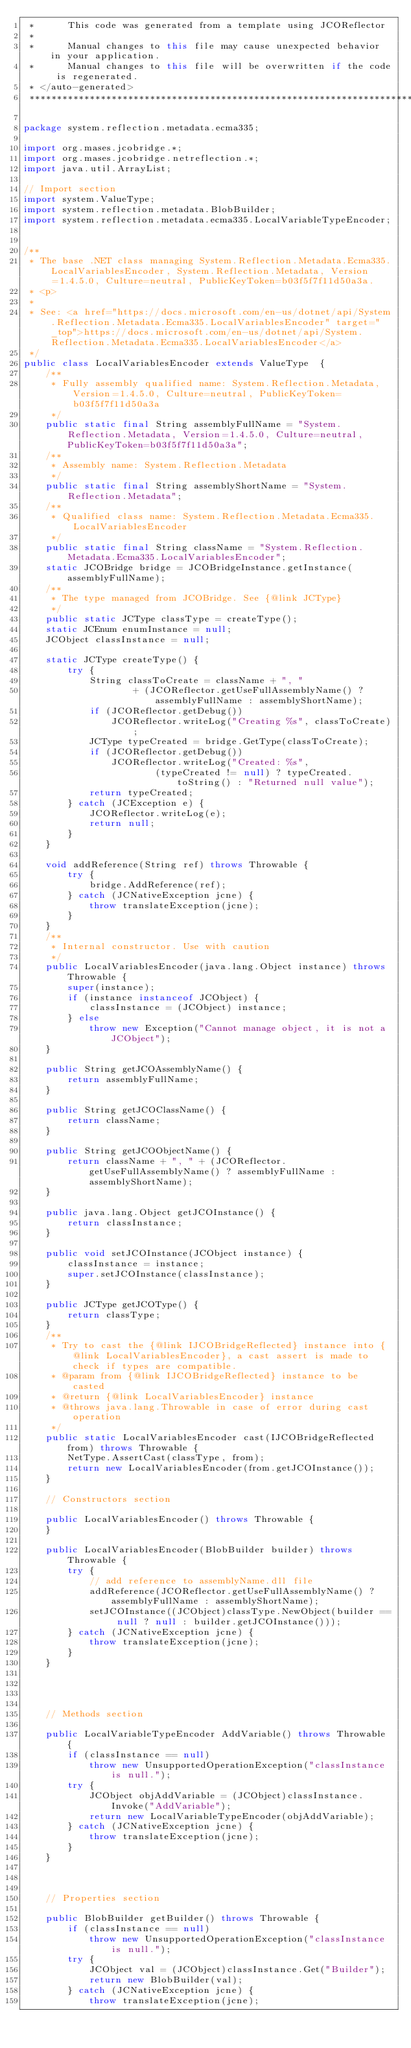Convert code to text. <code><loc_0><loc_0><loc_500><loc_500><_Java_> *      This code was generated from a template using JCOReflector
 * 
 *      Manual changes to this file may cause unexpected behavior in your application.
 *      Manual changes to this file will be overwritten if the code is regenerated.
 * </auto-generated>
 *************************************************************************************/

package system.reflection.metadata.ecma335;

import org.mases.jcobridge.*;
import org.mases.jcobridge.netreflection.*;
import java.util.ArrayList;

// Import section
import system.ValueType;
import system.reflection.metadata.BlobBuilder;
import system.reflection.metadata.ecma335.LocalVariableTypeEncoder;


/**
 * The base .NET class managing System.Reflection.Metadata.Ecma335.LocalVariablesEncoder, System.Reflection.Metadata, Version=1.4.5.0, Culture=neutral, PublicKeyToken=b03f5f7f11d50a3a.
 * <p>
 * 
 * See: <a href="https://docs.microsoft.com/en-us/dotnet/api/System.Reflection.Metadata.Ecma335.LocalVariablesEncoder" target="_top">https://docs.microsoft.com/en-us/dotnet/api/System.Reflection.Metadata.Ecma335.LocalVariablesEncoder</a>
 */
public class LocalVariablesEncoder extends ValueType  {
    /**
     * Fully assembly qualified name: System.Reflection.Metadata, Version=1.4.5.0, Culture=neutral, PublicKeyToken=b03f5f7f11d50a3a
     */
    public static final String assemblyFullName = "System.Reflection.Metadata, Version=1.4.5.0, Culture=neutral, PublicKeyToken=b03f5f7f11d50a3a";
    /**
     * Assembly name: System.Reflection.Metadata
     */
    public static final String assemblyShortName = "System.Reflection.Metadata";
    /**
     * Qualified class name: System.Reflection.Metadata.Ecma335.LocalVariablesEncoder
     */
    public static final String className = "System.Reflection.Metadata.Ecma335.LocalVariablesEncoder";
    static JCOBridge bridge = JCOBridgeInstance.getInstance(assemblyFullName);
    /**
     * The type managed from JCOBridge. See {@link JCType}
     */
    public static JCType classType = createType();
    static JCEnum enumInstance = null;
    JCObject classInstance = null;

    static JCType createType() {
        try {
            String classToCreate = className + ", "
                    + (JCOReflector.getUseFullAssemblyName() ? assemblyFullName : assemblyShortName);
            if (JCOReflector.getDebug())
                JCOReflector.writeLog("Creating %s", classToCreate);
            JCType typeCreated = bridge.GetType(classToCreate);
            if (JCOReflector.getDebug())
                JCOReflector.writeLog("Created: %s",
                        (typeCreated != null) ? typeCreated.toString() : "Returned null value");
            return typeCreated;
        } catch (JCException e) {
            JCOReflector.writeLog(e);
            return null;
        }
    }

    void addReference(String ref) throws Throwable {
        try {
            bridge.AddReference(ref);
        } catch (JCNativeException jcne) {
            throw translateException(jcne);
        }
    }
    /**
     * Internal constructor. Use with caution 
     */
    public LocalVariablesEncoder(java.lang.Object instance) throws Throwable {
        super(instance);
        if (instance instanceof JCObject) {
            classInstance = (JCObject) instance;
        } else
            throw new Exception("Cannot manage object, it is not a JCObject");
    }

    public String getJCOAssemblyName() {
        return assemblyFullName;
    }

    public String getJCOClassName() {
        return className;
    }

    public String getJCOObjectName() {
        return className + ", " + (JCOReflector.getUseFullAssemblyName() ? assemblyFullName : assemblyShortName);
    }

    public java.lang.Object getJCOInstance() {
        return classInstance;
    }

    public void setJCOInstance(JCObject instance) {
        classInstance = instance;
        super.setJCOInstance(classInstance);
    }

    public JCType getJCOType() {
        return classType;
    }
    /**
     * Try to cast the {@link IJCOBridgeReflected} instance into {@link LocalVariablesEncoder}, a cast assert is made to check if types are compatible.
     * @param from {@link IJCOBridgeReflected} instance to be casted
     * @return {@link LocalVariablesEncoder} instance
     * @throws java.lang.Throwable in case of error during cast operation
     */
    public static LocalVariablesEncoder cast(IJCOBridgeReflected from) throws Throwable {
        NetType.AssertCast(classType, from);
        return new LocalVariablesEncoder(from.getJCOInstance());
    }

    // Constructors section
    
    public LocalVariablesEncoder() throws Throwable {
    }

    public LocalVariablesEncoder(BlobBuilder builder) throws Throwable {
        try {
            // add reference to assemblyName.dll file
            addReference(JCOReflector.getUseFullAssemblyName() ? assemblyFullName : assemblyShortName);
            setJCOInstance((JCObject)classType.NewObject(builder == null ? null : builder.getJCOInstance()));
        } catch (JCNativeException jcne) {
            throw translateException(jcne);
        }
    }



    
    // Methods section
    
    public LocalVariableTypeEncoder AddVariable() throws Throwable {
        if (classInstance == null)
            throw new UnsupportedOperationException("classInstance is null.");
        try {
            JCObject objAddVariable = (JCObject)classInstance.Invoke("AddVariable");
            return new LocalVariableTypeEncoder(objAddVariable);
        } catch (JCNativeException jcne) {
            throw translateException(jcne);
        }
    }


    
    // Properties section
    
    public BlobBuilder getBuilder() throws Throwable {
        if (classInstance == null)
            throw new UnsupportedOperationException("classInstance is null.");
        try {
            JCObject val = (JCObject)classInstance.Get("Builder");
            return new BlobBuilder(val);
        } catch (JCNativeException jcne) {
            throw translateException(jcne);</code> 